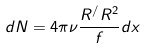<formula> <loc_0><loc_0><loc_500><loc_500>d N = 4 \pi \nu \frac { R ^ { / } R ^ { 2 } } f d x</formula> 